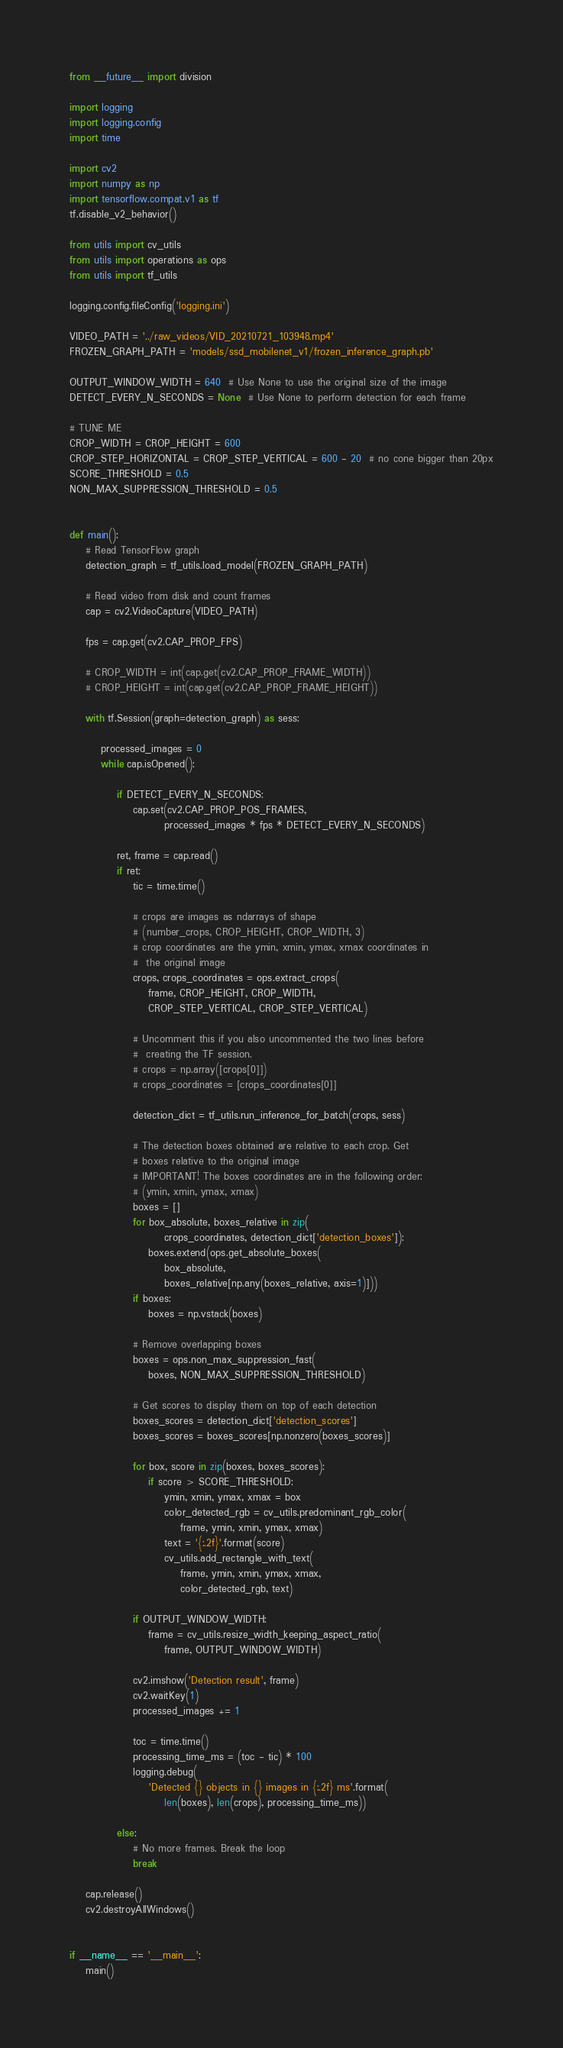Convert code to text. <code><loc_0><loc_0><loc_500><loc_500><_Python_>from __future__ import division

import logging
import logging.config
import time

import cv2
import numpy as np
import tensorflow.compat.v1 as tf
tf.disable_v2_behavior()

from utils import cv_utils
from utils import operations as ops
from utils import tf_utils

logging.config.fileConfig('logging.ini')

VIDEO_PATH = '../raw_videos/VID_20210721_103948.mp4'
FROZEN_GRAPH_PATH = 'models/ssd_mobilenet_v1/frozen_inference_graph.pb'

OUTPUT_WINDOW_WIDTH = 640  # Use None to use the original size of the image
DETECT_EVERY_N_SECONDS = None  # Use None to perform detection for each frame

# TUNE ME
CROP_WIDTH = CROP_HEIGHT = 600
CROP_STEP_HORIZONTAL = CROP_STEP_VERTICAL = 600 - 20  # no cone bigger than 20px
SCORE_THRESHOLD = 0.5
NON_MAX_SUPPRESSION_THRESHOLD = 0.5


def main():
    # Read TensorFlow graph
    detection_graph = tf_utils.load_model(FROZEN_GRAPH_PATH)

    # Read video from disk and count frames
    cap = cv2.VideoCapture(VIDEO_PATH)

    fps = cap.get(cv2.CAP_PROP_FPS)

    # CROP_WIDTH = int(cap.get(cv2.CAP_PROP_FRAME_WIDTH))
    # CROP_HEIGHT = int(cap.get(cv2.CAP_PROP_FRAME_HEIGHT))

    with tf.Session(graph=detection_graph) as sess:

        processed_images = 0
        while cap.isOpened():

            if DETECT_EVERY_N_SECONDS:
                cap.set(cv2.CAP_PROP_POS_FRAMES,
                        processed_images * fps * DETECT_EVERY_N_SECONDS)

            ret, frame = cap.read()
            if ret:
                tic = time.time()

                # crops are images as ndarrays of shape
                # (number_crops, CROP_HEIGHT, CROP_WIDTH, 3)
                # crop coordinates are the ymin, xmin, ymax, xmax coordinates in
                #  the original image
                crops, crops_coordinates = ops.extract_crops(
                    frame, CROP_HEIGHT, CROP_WIDTH,
                    CROP_STEP_VERTICAL, CROP_STEP_VERTICAL)

                # Uncomment this if you also uncommented the two lines before
                #  creating the TF session.
                # crops = np.array([crops[0]])
                # crops_coordinates = [crops_coordinates[0]]

                detection_dict = tf_utils.run_inference_for_batch(crops, sess)

                # The detection boxes obtained are relative to each crop. Get
                # boxes relative to the original image
                # IMPORTANT! The boxes coordinates are in the following order:
                # (ymin, xmin, ymax, xmax)
                boxes = []
                for box_absolute, boxes_relative in zip(
                        crops_coordinates, detection_dict['detection_boxes']):
                    boxes.extend(ops.get_absolute_boxes(
                        box_absolute,
                        boxes_relative[np.any(boxes_relative, axis=1)]))
                if boxes:
                    boxes = np.vstack(boxes)

                # Remove overlapping boxes
                boxes = ops.non_max_suppression_fast(
                    boxes, NON_MAX_SUPPRESSION_THRESHOLD)

                # Get scores to display them on top of each detection
                boxes_scores = detection_dict['detection_scores']
                boxes_scores = boxes_scores[np.nonzero(boxes_scores)]

                for box, score in zip(boxes, boxes_scores):
                    if score > SCORE_THRESHOLD:
                        ymin, xmin, ymax, xmax = box
                        color_detected_rgb = cv_utils.predominant_rgb_color(
                            frame, ymin, xmin, ymax, xmax)
                        text = '{:.2f}'.format(score)
                        cv_utils.add_rectangle_with_text(
                            frame, ymin, xmin, ymax, xmax,
                            color_detected_rgb, text)

                if OUTPUT_WINDOW_WIDTH:
                    frame = cv_utils.resize_width_keeping_aspect_ratio(
                        frame, OUTPUT_WINDOW_WIDTH)

                cv2.imshow('Detection result', frame)
                cv2.waitKey(1)
                processed_images += 1

                toc = time.time()
                processing_time_ms = (toc - tic) * 100
                logging.debug(
                    'Detected {} objects in {} images in {:.2f} ms'.format(
                        len(boxes), len(crops), processing_time_ms))

            else:
                # No more frames. Break the loop
                break

    cap.release()
    cv2.destroyAllWindows()


if __name__ == '__main__':
    main()
</code> 